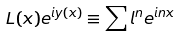<formula> <loc_0><loc_0><loc_500><loc_500>L ( x ) e ^ { i y ( x ) } \equiv \sum l ^ { n } e ^ { i n x }</formula> 